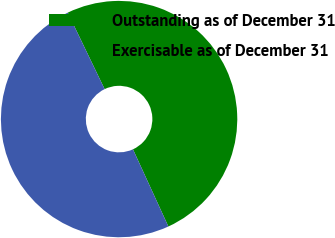Convert chart to OTSL. <chart><loc_0><loc_0><loc_500><loc_500><pie_chart><fcel>Outstanding as of December 31<fcel>Exercisable as of December 31<nl><fcel>50.31%<fcel>49.69%<nl></chart> 